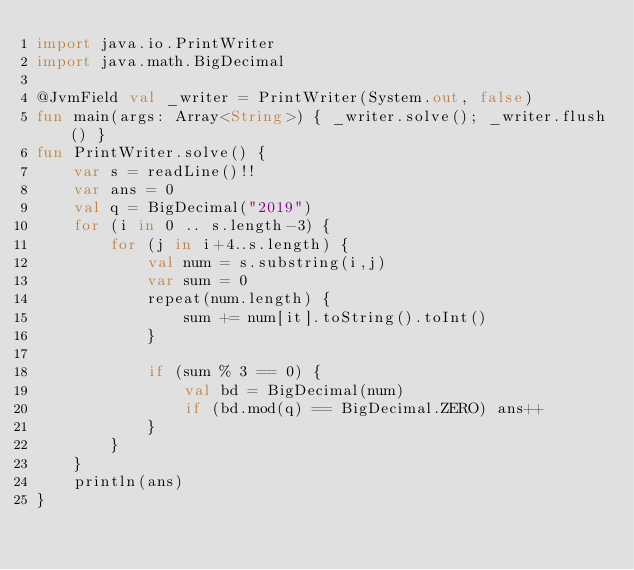Convert code to text. <code><loc_0><loc_0><loc_500><loc_500><_Kotlin_>import java.io.PrintWriter
import java.math.BigDecimal

@JvmField val _writer = PrintWriter(System.out, false)
fun main(args: Array<String>) { _writer.solve(); _writer.flush() }
fun PrintWriter.solve() {
    var s = readLine()!!
    var ans = 0
    val q = BigDecimal("2019")
    for (i in 0 .. s.length-3) {
        for (j in i+4..s.length) {
            val num = s.substring(i,j)
            var sum = 0
            repeat(num.length) {
                sum += num[it].toString().toInt()
            }

            if (sum % 3 == 0) {
                val bd = BigDecimal(num)
                if (bd.mod(q) == BigDecimal.ZERO) ans++
            }
        }
    }
    println(ans)
}
</code> 